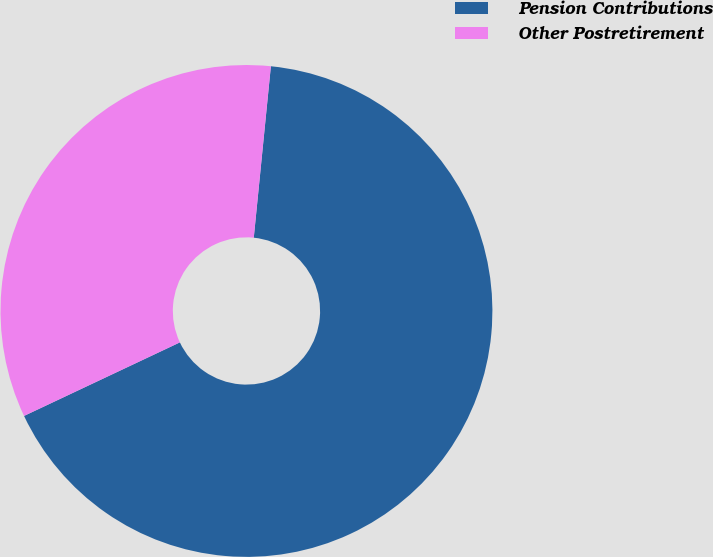<chart> <loc_0><loc_0><loc_500><loc_500><pie_chart><fcel>Pension Contributions<fcel>Other Postretirement<nl><fcel>66.4%<fcel>33.6%<nl></chart> 